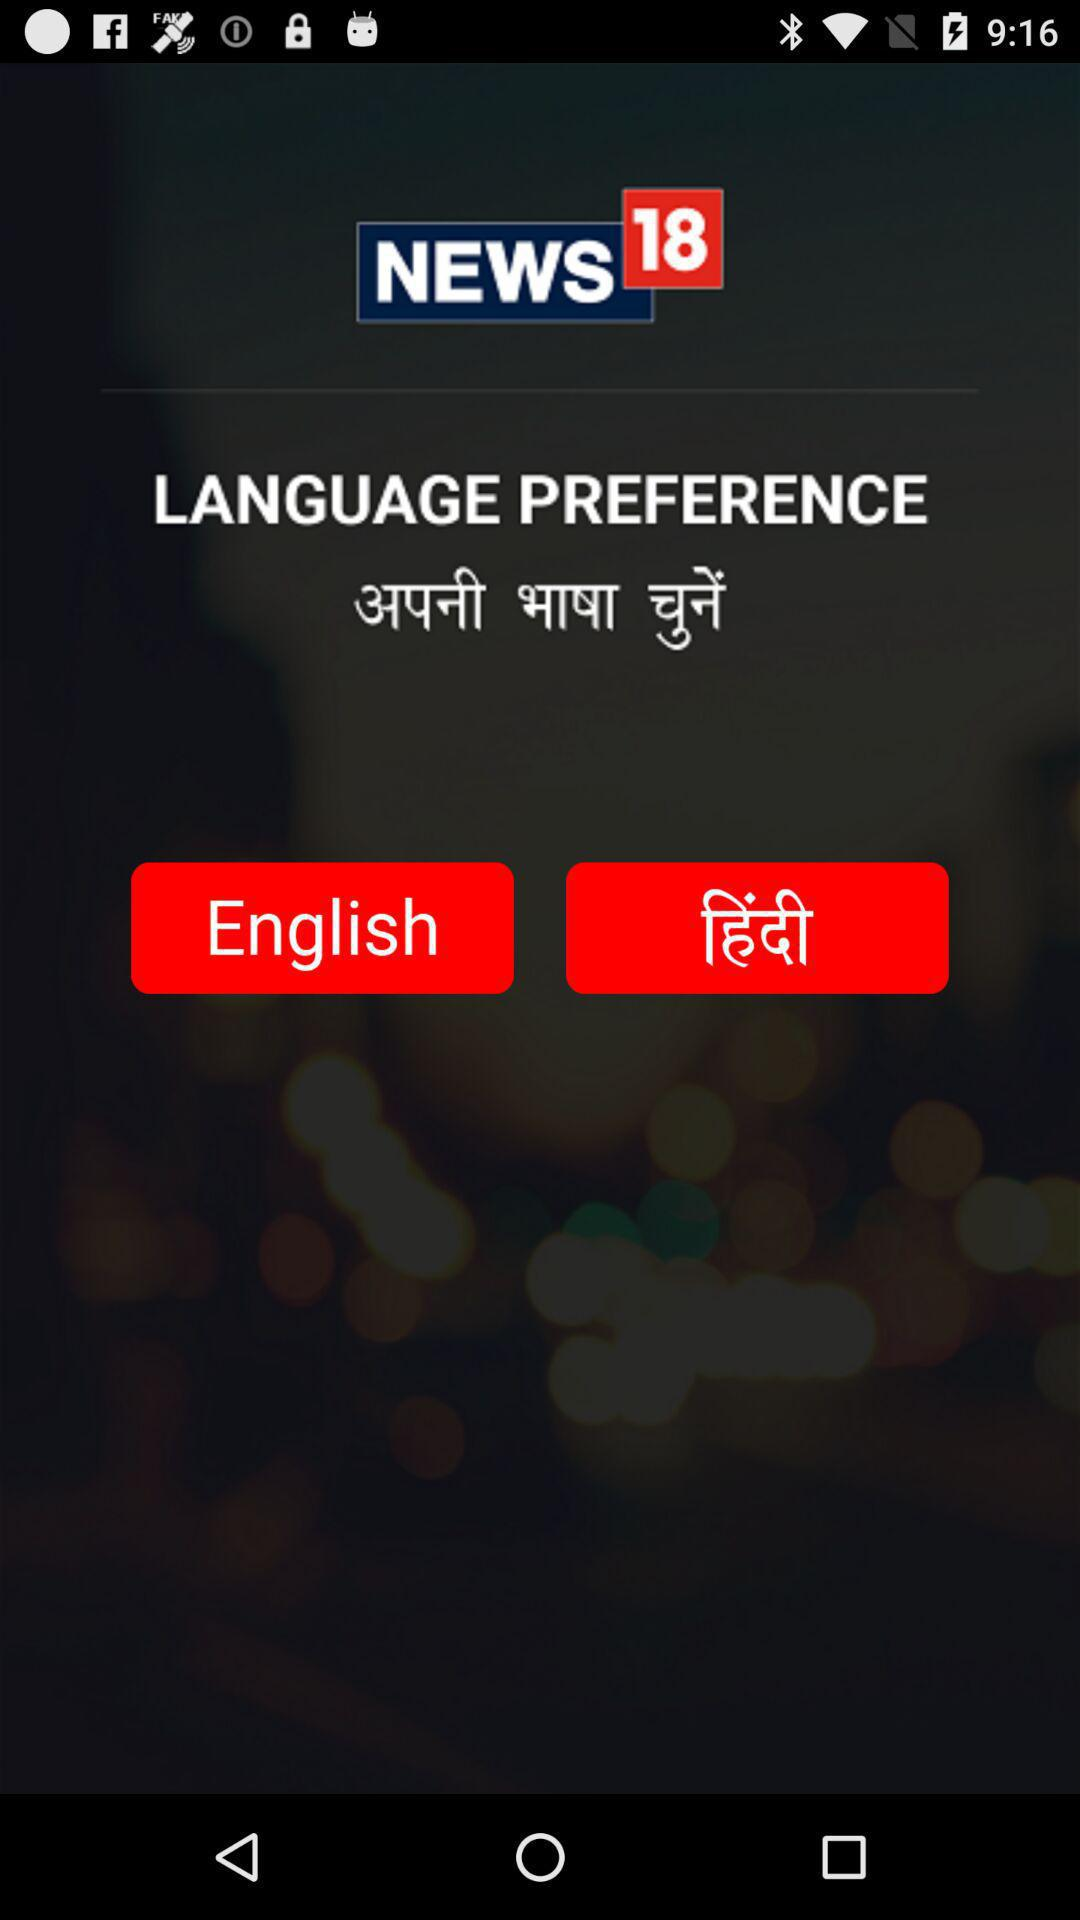What is the application name? The application name is "News18". 